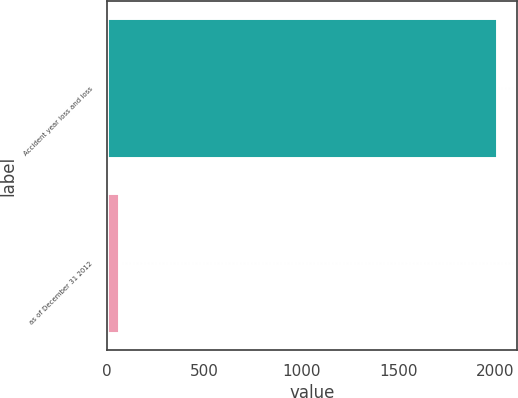<chart> <loc_0><loc_0><loc_500><loc_500><bar_chart><fcel>Accident year loss and loss<fcel>as of December 31 2012<nl><fcel>2010<fcel>60.4<nl></chart> 